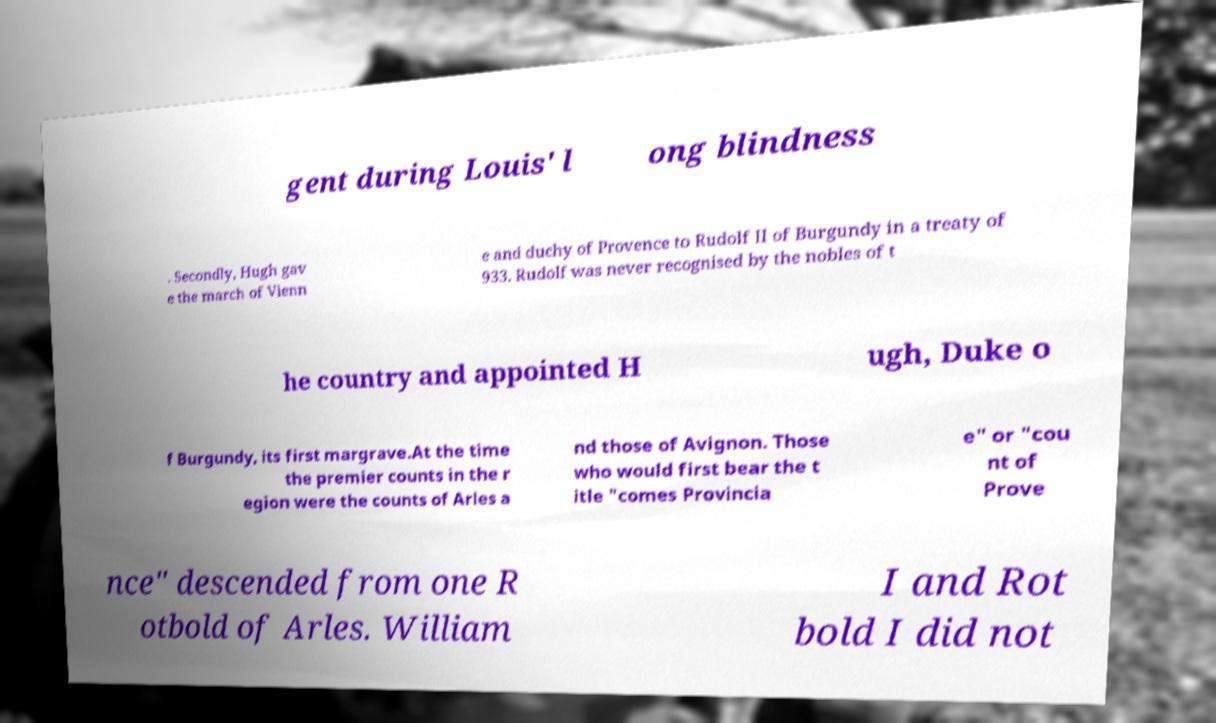Please identify and transcribe the text found in this image. gent during Louis' l ong blindness . Secondly, Hugh gav e the march of Vienn e and duchy of Provence to Rudolf II of Burgundy in a treaty of 933. Rudolf was never recognised by the nobles of t he country and appointed H ugh, Duke o f Burgundy, its first margrave.At the time the premier counts in the r egion were the counts of Arles a nd those of Avignon. Those who would first bear the t itle "comes Provincia e" or "cou nt of Prove nce" descended from one R otbold of Arles. William I and Rot bold I did not 